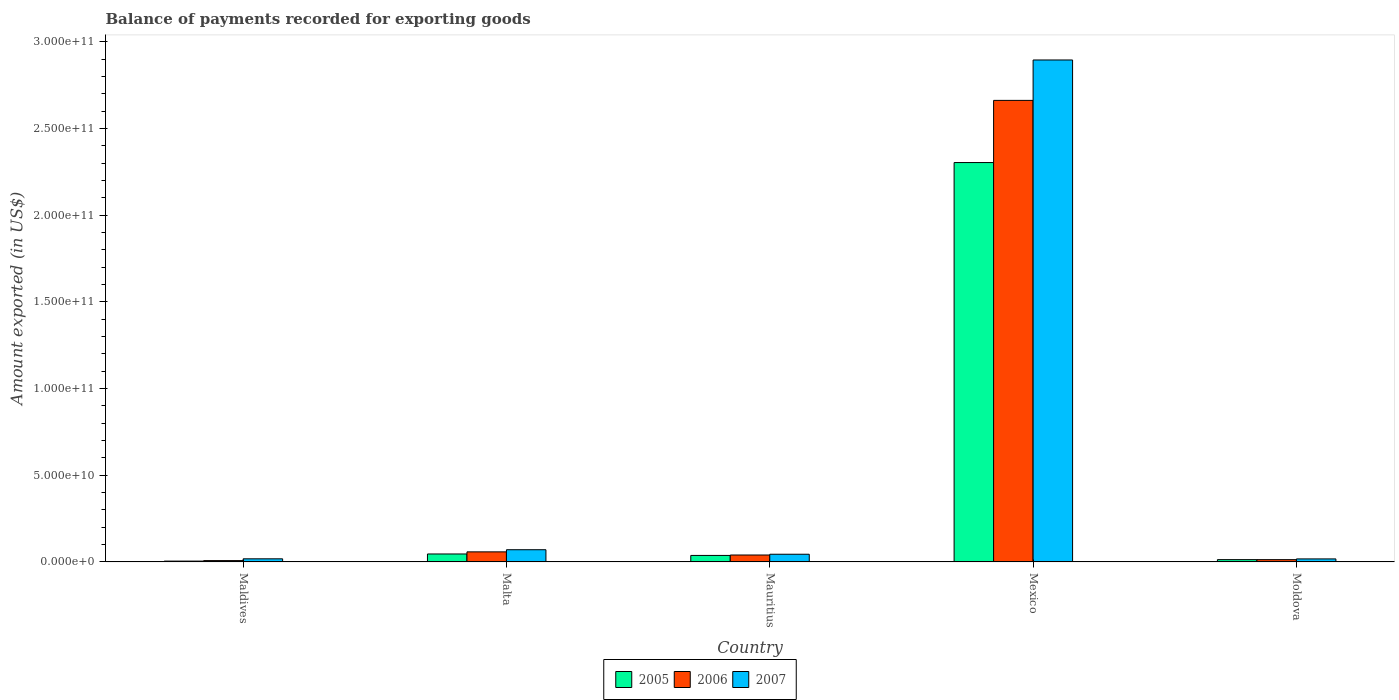How many groups of bars are there?
Offer a very short reply. 5. Are the number of bars per tick equal to the number of legend labels?
Provide a succinct answer. Yes. Are the number of bars on each tick of the X-axis equal?
Keep it short and to the point. Yes. How many bars are there on the 5th tick from the right?
Provide a succinct answer. 3. What is the label of the 3rd group of bars from the left?
Offer a very short reply. Mauritius. What is the amount exported in 2006 in Mexico?
Keep it short and to the point. 2.66e+11. Across all countries, what is the maximum amount exported in 2005?
Make the answer very short. 2.30e+11. Across all countries, what is the minimum amount exported in 2005?
Keep it short and to the point. 4.85e+08. In which country was the amount exported in 2006 maximum?
Make the answer very short. Mexico. In which country was the amount exported in 2006 minimum?
Your answer should be very brief. Maldives. What is the total amount exported in 2007 in the graph?
Your response must be concise. 3.05e+11. What is the difference between the amount exported in 2006 in Malta and that in Mauritius?
Offer a very short reply. 1.81e+09. What is the difference between the amount exported in 2006 in Malta and the amount exported in 2005 in Maldives?
Your answer should be very brief. 5.33e+09. What is the average amount exported in 2006 per country?
Ensure brevity in your answer.  5.56e+1. What is the difference between the amount exported of/in 2007 and amount exported of/in 2005 in Maldives?
Offer a very short reply. 1.32e+09. What is the ratio of the amount exported in 2007 in Mauritius to that in Mexico?
Provide a succinct answer. 0.02. Is the amount exported in 2006 in Malta less than that in Mexico?
Give a very brief answer. Yes. Is the difference between the amount exported in 2007 in Mauritius and Mexico greater than the difference between the amount exported in 2005 in Mauritius and Mexico?
Give a very brief answer. No. What is the difference between the highest and the second highest amount exported in 2006?
Give a very brief answer. 2.60e+11. What is the difference between the highest and the lowest amount exported in 2005?
Ensure brevity in your answer.  2.30e+11. In how many countries, is the amount exported in 2005 greater than the average amount exported in 2005 taken over all countries?
Your answer should be compact. 1. What does the 3rd bar from the right in Mexico represents?
Offer a very short reply. 2005. Is it the case that in every country, the sum of the amount exported in 2006 and amount exported in 2007 is greater than the amount exported in 2005?
Your response must be concise. Yes. Are all the bars in the graph horizontal?
Keep it short and to the point. No. How many countries are there in the graph?
Your answer should be compact. 5. What is the difference between two consecutive major ticks on the Y-axis?
Provide a succinct answer. 5.00e+1. Are the values on the major ticks of Y-axis written in scientific E-notation?
Keep it short and to the point. Yes. Does the graph contain any zero values?
Provide a short and direct response. No. What is the title of the graph?
Provide a succinct answer. Balance of payments recorded for exporting goods. Does "1991" appear as one of the legend labels in the graph?
Provide a succinct answer. No. What is the label or title of the X-axis?
Provide a succinct answer. Country. What is the label or title of the Y-axis?
Ensure brevity in your answer.  Amount exported (in US$). What is the Amount exported (in US$) of 2005 in Maldives?
Provide a succinct answer. 4.85e+08. What is the Amount exported (in US$) of 2006 in Maldives?
Keep it short and to the point. 7.77e+08. What is the Amount exported (in US$) in 2007 in Maldives?
Provide a short and direct response. 1.80e+09. What is the Amount exported (in US$) of 2005 in Malta?
Your answer should be very brief. 4.59e+09. What is the Amount exported (in US$) of 2006 in Malta?
Offer a very short reply. 5.81e+09. What is the Amount exported (in US$) of 2007 in Malta?
Make the answer very short. 7.05e+09. What is the Amount exported (in US$) in 2005 in Mauritius?
Provide a short and direct response. 3.76e+09. What is the Amount exported (in US$) in 2006 in Mauritius?
Make the answer very short. 4.00e+09. What is the Amount exported (in US$) in 2007 in Mauritius?
Provide a succinct answer. 4.44e+09. What is the Amount exported (in US$) in 2005 in Mexico?
Offer a terse response. 2.30e+11. What is the Amount exported (in US$) in 2006 in Mexico?
Offer a very short reply. 2.66e+11. What is the Amount exported (in US$) in 2007 in Mexico?
Ensure brevity in your answer.  2.90e+11. What is the Amount exported (in US$) in 2005 in Moldova?
Give a very brief answer. 1.33e+09. What is the Amount exported (in US$) of 2006 in Moldova?
Offer a terse response. 1.32e+09. What is the Amount exported (in US$) in 2007 in Moldova?
Your answer should be very brief. 1.75e+09. Across all countries, what is the maximum Amount exported (in US$) in 2005?
Keep it short and to the point. 2.30e+11. Across all countries, what is the maximum Amount exported (in US$) in 2006?
Provide a short and direct response. 2.66e+11. Across all countries, what is the maximum Amount exported (in US$) of 2007?
Your response must be concise. 2.90e+11. Across all countries, what is the minimum Amount exported (in US$) of 2005?
Offer a terse response. 4.85e+08. Across all countries, what is the minimum Amount exported (in US$) in 2006?
Give a very brief answer. 7.77e+08. Across all countries, what is the minimum Amount exported (in US$) of 2007?
Offer a very short reply. 1.75e+09. What is the total Amount exported (in US$) in 2005 in the graph?
Ensure brevity in your answer.  2.41e+11. What is the total Amount exported (in US$) of 2006 in the graph?
Provide a succinct answer. 2.78e+11. What is the total Amount exported (in US$) in 2007 in the graph?
Your answer should be compact. 3.05e+11. What is the difference between the Amount exported (in US$) in 2005 in Maldives and that in Malta?
Provide a succinct answer. -4.11e+09. What is the difference between the Amount exported (in US$) in 2006 in Maldives and that in Malta?
Your answer should be very brief. -5.03e+09. What is the difference between the Amount exported (in US$) in 2007 in Maldives and that in Malta?
Ensure brevity in your answer.  -5.25e+09. What is the difference between the Amount exported (in US$) of 2005 in Maldives and that in Mauritius?
Your answer should be very brief. -3.27e+09. What is the difference between the Amount exported (in US$) in 2006 in Maldives and that in Mauritius?
Keep it short and to the point. -3.22e+09. What is the difference between the Amount exported (in US$) in 2007 in Maldives and that in Mauritius?
Your answer should be compact. -2.64e+09. What is the difference between the Amount exported (in US$) in 2005 in Maldives and that in Mexico?
Give a very brief answer. -2.30e+11. What is the difference between the Amount exported (in US$) of 2006 in Maldives and that in Mexico?
Offer a very short reply. -2.65e+11. What is the difference between the Amount exported (in US$) in 2007 in Maldives and that in Mexico?
Make the answer very short. -2.88e+11. What is the difference between the Amount exported (in US$) in 2005 in Maldives and that in Moldova?
Provide a short and direct response. -8.48e+08. What is the difference between the Amount exported (in US$) in 2006 in Maldives and that in Moldova?
Provide a succinct answer. -5.45e+08. What is the difference between the Amount exported (in US$) in 2007 in Maldives and that in Moldova?
Keep it short and to the point. 5.84e+07. What is the difference between the Amount exported (in US$) in 2005 in Malta and that in Mauritius?
Make the answer very short. 8.36e+08. What is the difference between the Amount exported (in US$) in 2006 in Malta and that in Mauritius?
Your response must be concise. 1.81e+09. What is the difference between the Amount exported (in US$) in 2007 in Malta and that in Mauritius?
Provide a succinct answer. 2.61e+09. What is the difference between the Amount exported (in US$) of 2005 in Malta and that in Mexico?
Give a very brief answer. -2.26e+11. What is the difference between the Amount exported (in US$) of 2006 in Malta and that in Mexico?
Your answer should be compact. -2.60e+11. What is the difference between the Amount exported (in US$) in 2007 in Malta and that in Mexico?
Your response must be concise. -2.82e+11. What is the difference between the Amount exported (in US$) in 2005 in Malta and that in Moldova?
Provide a short and direct response. 3.26e+09. What is the difference between the Amount exported (in US$) of 2006 in Malta and that in Moldova?
Keep it short and to the point. 4.49e+09. What is the difference between the Amount exported (in US$) of 2007 in Malta and that in Moldova?
Offer a terse response. 5.30e+09. What is the difference between the Amount exported (in US$) of 2005 in Mauritius and that in Mexico?
Your response must be concise. -2.27e+11. What is the difference between the Amount exported (in US$) of 2006 in Mauritius and that in Mexico?
Offer a very short reply. -2.62e+11. What is the difference between the Amount exported (in US$) of 2007 in Mauritius and that in Mexico?
Ensure brevity in your answer.  -2.85e+11. What is the difference between the Amount exported (in US$) in 2005 in Mauritius and that in Moldova?
Provide a short and direct response. 2.42e+09. What is the difference between the Amount exported (in US$) in 2006 in Mauritius and that in Moldova?
Give a very brief answer. 2.68e+09. What is the difference between the Amount exported (in US$) of 2007 in Mauritius and that in Moldova?
Offer a terse response. 2.70e+09. What is the difference between the Amount exported (in US$) of 2005 in Mexico and that in Moldova?
Your answer should be very brief. 2.29e+11. What is the difference between the Amount exported (in US$) of 2006 in Mexico and that in Moldova?
Offer a terse response. 2.65e+11. What is the difference between the Amount exported (in US$) in 2007 in Mexico and that in Moldova?
Make the answer very short. 2.88e+11. What is the difference between the Amount exported (in US$) in 2005 in Maldives and the Amount exported (in US$) in 2006 in Malta?
Provide a succinct answer. -5.33e+09. What is the difference between the Amount exported (in US$) in 2005 in Maldives and the Amount exported (in US$) in 2007 in Malta?
Keep it short and to the point. -6.57e+09. What is the difference between the Amount exported (in US$) in 2006 in Maldives and the Amount exported (in US$) in 2007 in Malta?
Ensure brevity in your answer.  -6.27e+09. What is the difference between the Amount exported (in US$) in 2005 in Maldives and the Amount exported (in US$) in 2006 in Mauritius?
Your answer should be compact. -3.52e+09. What is the difference between the Amount exported (in US$) in 2005 in Maldives and the Amount exported (in US$) in 2007 in Mauritius?
Give a very brief answer. -3.96e+09. What is the difference between the Amount exported (in US$) in 2006 in Maldives and the Amount exported (in US$) in 2007 in Mauritius?
Provide a succinct answer. -3.67e+09. What is the difference between the Amount exported (in US$) of 2005 in Maldives and the Amount exported (in US$) of 2006 in Mexico?
Give a very brief answer. -2.66e+11. What is the difference between the Amount exported (in US$) in 2005 in Maldives and the Amount exported (in US$) in 2007 in Mexico?
Offer a very short reply. -2.89e+11. What is the difference between the Amount exported (in US$) in 2006 in Maldives and the Amount exported (in US$) in 2007 in Mexico?
Give a very brief answer. -2.89e+11. What is the difference between the Amount exported (in US$) in 2005 in Maldives and the Amount exported (in US$) in 2006 in Moldova?
Provide a succinct answer. -8.38e+08. What is the difference between the Amount exported (in US$) of 2005 in Maldives and the Amount exported (in US$) of 2007 in Moldova?
Keep it short and to the point. -1.26e+09. What is the difference between the Amount exported (in US$) of 2006 in Maldives and the Amount exported (in US$) of 2007 in Moldova?
Offer a very short reply. -9.68e+08. What is the difference between the Amount exported (in US$) in 2005 in Malta and the Amount exported (in US$) in 2006 in Mauritius?
Your answer should be very brief. 5.92e+08. What is the difference between the Amount exported (in US$) in 2005 in Malta and the Amount exported (in US$) in 2007 in Mauritius?
Give a very brief answer. 1.49e+08. What is the difference between the Amount exported (in US$) in 2006 in Malta and the Amount exported (in US$) in 2007 in Mauritius?
Keep it short and to the point. 1.37e+09. What is the difference between the Amount exported (in US$) in 2005 in Malta and the Amount exported (in US$) in 2006 in Mexico?
Provide a short and direct response. -2.62e+11. What is the difference between the Amount exported (in US$) in 2005 in Malta and the Amount exported (in US$) in 2007 in Mexico?
Your answer should be compact. -2.85e+11. What is the difference between the Amount exported (in US$) in 2006 in Malta and the Amount exported (in US$) in 2007 in Mexico?
Provide a succinct answer. -2.84e+11. What is the difference between the Amount exported (in US$) in 2005 in Malta and the Amount exported (in US$) in 2006 in Moldova?
Your answer should be very brief. 3.27e+09. What is the difference between the Amount exported (in US$) of 2005 in Malta and the Amount exported (in US$) of 2007 in Moldova?
Make the answer very short. 2.85e+09. What is the difference between the Amount exported (in US$) in 2006 in Malta and the Amount exported (in US$) in 2007 in Moldova?
Provide a succinct answer. 4.07e+09. What is the difference between the Amount exported (in US$) in 2005 in Mauritius and the Amount exported (in US$) in 2006 in Mexico?
Give a very brief answer. -2.62e+11. What is the difference between the Amount exported (in US$) in 2005 in Mauritius and the Amount exported (in US$) in 2007 in Mexico?
Your response must be concise. -2.86e+11. What is the difference between the Amount exported (in US$) in 2006 in Mauritius and the Amount exported (in US$) in 2007 in Mexico?
Offer a terse response. -2.86e+11. What is the difference between the Amount exported (in US$) in 2005 in Mauritius and the Amount exported (in US$) in 2006 in Moldova?
Your response must be concise. 2.43e+09. What is the difference between the Amount exported (in US$) of 2005 in Mauritius and the Amount exported (in US$) of 2007 in Moldova?
Make the answer very short. 2.01e+09. What is the difference between the Amount exported (in US$) in 2006 in Mauritius and the Amount exported (in US$) in 2007 in Moldova?
Offer a very short reply. 2.25e+09. What is the difference between the Amount exported (in US$) of 2005 in Mexico and the Amount exported (in US$) of 2006 in Moldova?
Make the answer very short. 2.29e+11. What is the difference between the Amount exported (in US$) of 2005 in Mexico and the Amount exported (in US$) of 2007 in Moldova?
Make the answer very short. 2.29e+11. What is the difference between the Amount exported (in US$) of 2006 in Mexico and the Amount exported (in US$) of 2007 in Moldova?
Give a very brief answer. 2.64e+11. What is the average Amount exported (in US$) in 2005 per country?
Provide a short and direct response. 4.81e+1. What is the average Amount exported (in US$) in 2006 per country?
Ensure brevity in your answer.  5.56e+1. What is the average Amount exported (in US$) in 2007 per country?
Make the answer very short. 6.09e+1. What is the difference between the Amount exported (in US$) of 2005 and Amount exported (in US$) of 2006 in Maldives?
Ensure brevity in your answer.  -2.93e+08. What is the difference between the Amount exported (in US$) in 2005 and Amount exported (in US$) in 2007 in Maldives?
Keep it short and to the point. -1.32e+09. What is the difference between the Amount exported (in US$) in 2006 and Amount exported (in US$) in 2007 in Maldives?
Keep it short and to the point. -1.03e+09. What is the difference between the Amount exported (in US$) of 2005 and Amount exported (in US$) of 2006 in Malta?
Keep it short and to the point. -1.22e+09. What is the difference between the Amount exported (in US$) in 2005 and Amount exported (in US$) in 2007 in Malta?
Your answer should be compact. -2.46e+09. What is the difference between the Amount exported (in US$) of 2006 and Amount exported (in US$) of 2007 in Malta?
Keep it short and to the point. -1.24e+09. What is the difference between the Amount exported (in US$) of 2005 and Amount exported (in US$) of 2006 in Mauritius?
Make the answer very short. -2.44e+08. What is the difference between the Amount exported (in US$) in 2005 and Amount exported (in US$) in 2007 in Mauritius?
Your answer should be very brief. -6.87e+08. What is the difference between the Amount exported (in US$) of 2006 and Amount exported (in US$) of 2007 in Mauritius?
Ensure brevity in your answer.  -4.43e+08. What is the difference between the Amount exported (in US$) in 2005 and Amount exported (in US$) in 2006 in Mexico?
Ensure brevity in your answer.  -3.59e+1. What is the difference between the Amount exported (in US$) in 2005 and Amount exported (in US$) in 2007 in Mexico?
Your answer should be compact. -5.92e+1. What is the difference between the Amount exported (in US$) of 2006 and Amount exported (in US$) of 2007 in Mexico?
Your answer should be compact. -2.33e+1. What is the difference between the Amount exported (in US$) in 2005 and Amount exported (in US$) in 2006 in Moldova?
Provide a succinct answer. 1.02e+07. What is the difference between the Amount exported (in US$) in 2005 and Amount exported (in US$) in 2007 in Moldova?
Provide a succinct answer. -4.13e+08. What is the difference between the Amount exported (in US$) of 2006 and Amount exported (in US$) of 2007 in Moldova?
Your answer should be compact. -4.23e+08. What is the ratio of the Amount exported (in US$) of 2005 in Maldives to that in Malta?
Provide a short and direct response. 0.11. What is the ratio of the Amount exported (in US$) in 2006 in Maldives to that in Malta?
Provide a short and direct response. 0.13. What is the ratio of the Amount exported (in US$) in 2007 in Maldives to that in Malta?
Offer a very short reply. 0.26. What is the ratio of the Amount exported (in US$) of 2005 in Maldives to that in Mauritius?
Make the answer very short. 0.13. What is the ratio of the Amount exported (in US$) in 2006 in Maldives to that in Mauritius?
Offer a terse response. 0.19. What is the ratio of the Amount exported (in US$) of 2007 in Maldives to that in Mauritius?
Ensure brevity in your answer.  0.41. What is the ratio of the Amount exported (in US$) of 2005 in Maldives to that in Mexico?
Ensure brevity in your answer.  0. What is the ratio of the Amount exported (in US$) of 2006 in Maldives to that in Mexico?
Keep it short and to the point. 0. What is the ratio of the Amount exported (in US$) of 2007 in Maldives to that in Mexico?
Make the answer very short. 0.01. What is the ratio of the Amount exported (in US$) in 2005 in Maldives to that in Moldova?
Provide a short and direct response. 0.36. What is the ratio of the Amount exported (in US$) in 2006 in Maldives to that in Moldova?
Your response must be concise. 0.59. What is the ratio of the Amount exported (in US$) in 2007 in Maldives to that in Moldova?
Ensure brevity in your answer.  1.03. What is the ratio of the Amount exported (in US$) in 2005 in Malta to that in Mauritius?
Your response must be concise. 1.22. What is the ratio of the Amount exported (in US$) of 2006 in Malta to that in Mauritius?
Your answer should be very brief. 1.45. What is the ratio of the Amount exported (in US$) in 2007 in Malta to that in Mauritius?
Your response must be concise. 1.59. What is the ratio of the Amount exported (in US$) of 2005 in Malta to that in Mexico?
Offer a very short reply. 0.02. What is the ratio of the Amount exported (in US$) in 2006 in Malta to that in Mexico?
Your answer should be compact. 0.02. What is the ratio of the Amount exported (in US$) of 2007 in Malta to that in Mexico?
Offer a very short reply. 0.02. What is the ratio of the Amount exported (in US$) in 2005 in Malta to that in Moldova?
Offer a very short reply. 3.45. What is the ratio of the Amount exported (in US$) in 2006 in Malta to that in Moldova?
Your answer should be very brief. 4.4. What is the ratio of the Amount exported (in US$) of 2007 in Malta to that in Moldova?
Your answer should be compact. 4.04. What is the ratio of the Amount exported (in US$) in 2005 in Mauritius to that in Mexico?
Offer a very short reply. 0.02. What is the ratio of the Amount exported (in US$) in 2006 in Mauritius to that in Mexico?
Your response must be concise. 0.01. What is the ratio of the Amount exported (in US$) in 2007 in Mauritius to that in Mexico?
Give a very brief answer. 0.02. What is the ratio of the Amount exported (in US$) of 2005 in Mauritius to that in Moldova?
Ensure brevity in your answer.  2.82. What is the ratio of the Amount exported (in US$) in 2006 in Mauritius to that in Moldova?
Make the answer very short. 3.03. What is the ratio of the Amount exported (in US$) in 2007 in Mauritius to that in Moldova?
Offer a terse response. 2.55. What is the ratio of the Amount exported (in US$) of 2005 in Mexico to that in Moldova?
Give a very brief answer. 172.92. What is the ratio of the Amount exported (in US$) in 2006 in Mexico to that in Moldova?
Ensure brevity in your answer.  201.37. What is the ratio of the Amount exported (in US$) of 2007 in Mexico to that in Moldova?
Provide a short and direct response. 165.88. What is the difference between the highest and the second highest Amount exported (in US$) of 2005?
Your response must be concise. 2.26e+11. What is the difference between the highest and the second highest Amount exported (in US$) in 2006?
Provide a succinct answer. 2.60e+11. What is the difference between the highest and the second highest Amount exported (in US$) of 2007?
Ensure brevity in your answer.  2.82e+11. What is the difference between the highest and the lowest Amount exported (in US$) in 2005?
Make the answer very short. 2.30e+11. What is the difference between the highest and the lowest Amount exported (in US$) in 2006?
Make the answer very short. 2.65e+11. What is the difference between the highest and the lowest Amount exported (in US$) in 2007?
Offer a very short reply. 2.88e+11. 